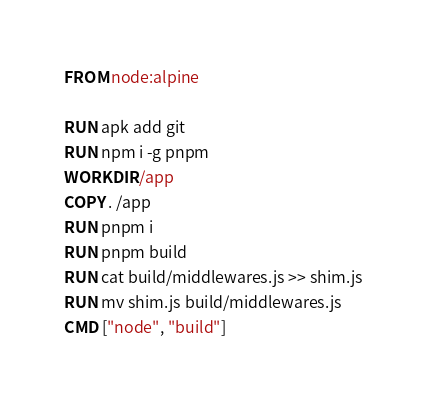<code> <loc_0><loc_0><loc_500><loc_500><_Dockerfile_>FROM node:alpine

RUN apk add git
RUN npm i -g pnpm
WORKDIR /app
COPY . /app
RUN pnpm i
RUN pnpm build
RUN cat build/middlewares.js >> shim.js
RUN mv shim.js build/middlewares.js
CMD ["node", "build"]
</code> 